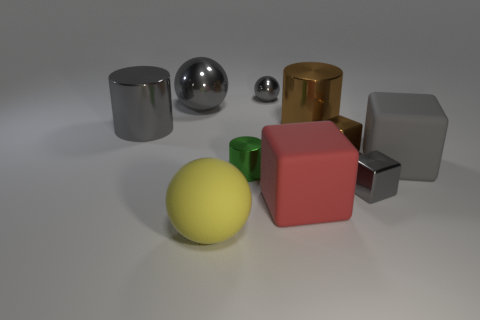Subtract 1 balls. How many balls are left? 2 Subtract all spheres. How many objects are left? 7 Subtract all big cylinders. Subtract all tiny brown things. How many objects are left? 7 Add 4 blocks. How many blocks are left? 8 Add 4 large green things. How many large green things exist? 4 Subtract 0 blue cylinders. How many objects are left? 10 